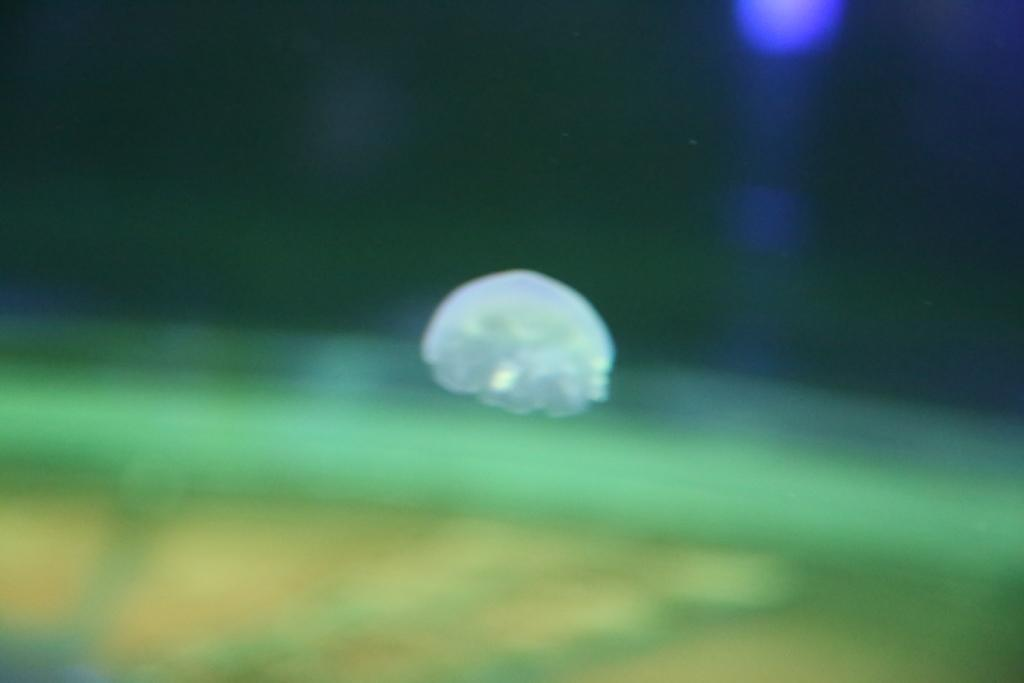What type of pleasure can be experienced from the flavor of the moon in the image? There is no moon or flavor present in the image, so it is not possible to experience any pleasure from them. 